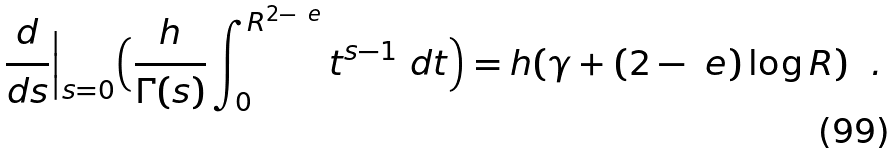Convert formula to latex. <formula><loc_0><loc_0><loc_500><loc_500>\frac { d } { d s } \Big | _ { s = 0 } \Big ( \frac { h } { \Gamma ( s ) } \int ^ { R ^ { 2 - \ e } } _ { 0 } t ^ { s - 1 } \ d t \Big ) = h ( \gamma + { ( 2 - \ e ) } \log R ) \ \ .</formula> 